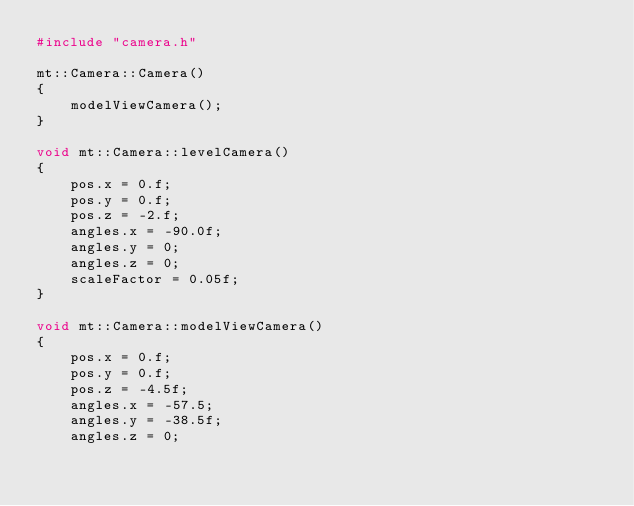Convert code to text. <code><loc_0><loc_0><loc_500><loc_500><_C++_>#include "camera.h"

mt::Camera::Camera()
{
	modelViewCamera();
}

void mt::Camera::levelCamera()
{
	pos.x = 0.f;
	pos.y = 0.f;
	pos.z = -2.f;
	angles.x = -90.0f;
	angles.y = 0;
	angles.z = 0;
	scaleFactor = 0.05f;
}

void mt::Camera::modelViewCamera()
{
	pos.x = 0.f;
	pos.y = 0.f;
	pos.z = -4.5f;
	angles.x = -57.5;
	angles.y = -38.5f;
	angles.z = 0;</code> 